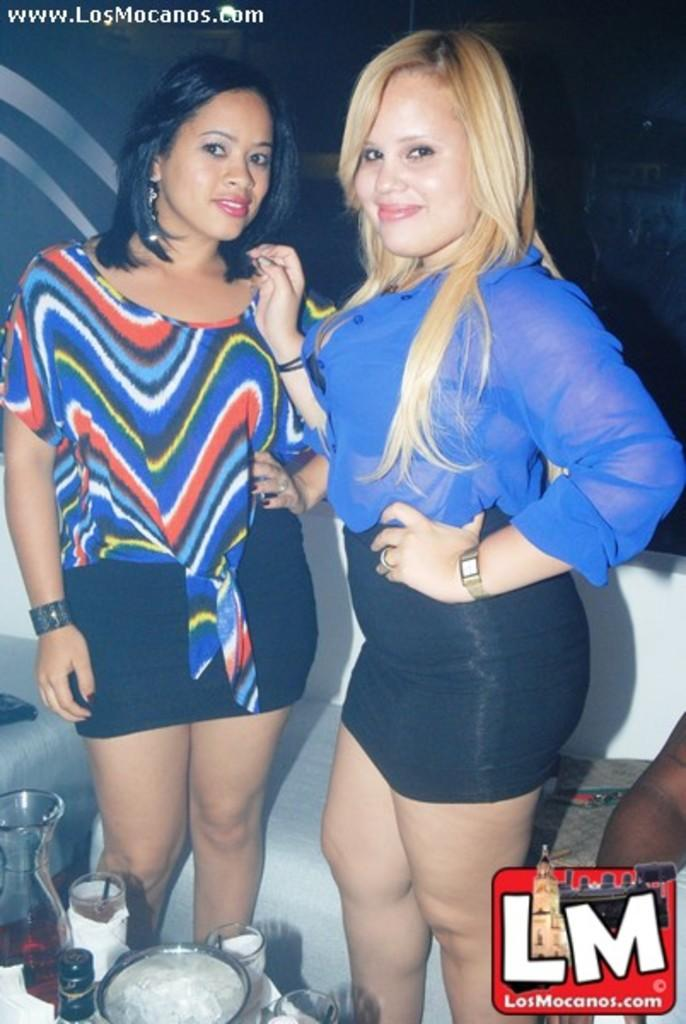Provide a one-sentence caption for the provided image. A photo featuring two women is hosted on the LosMonacos website. 